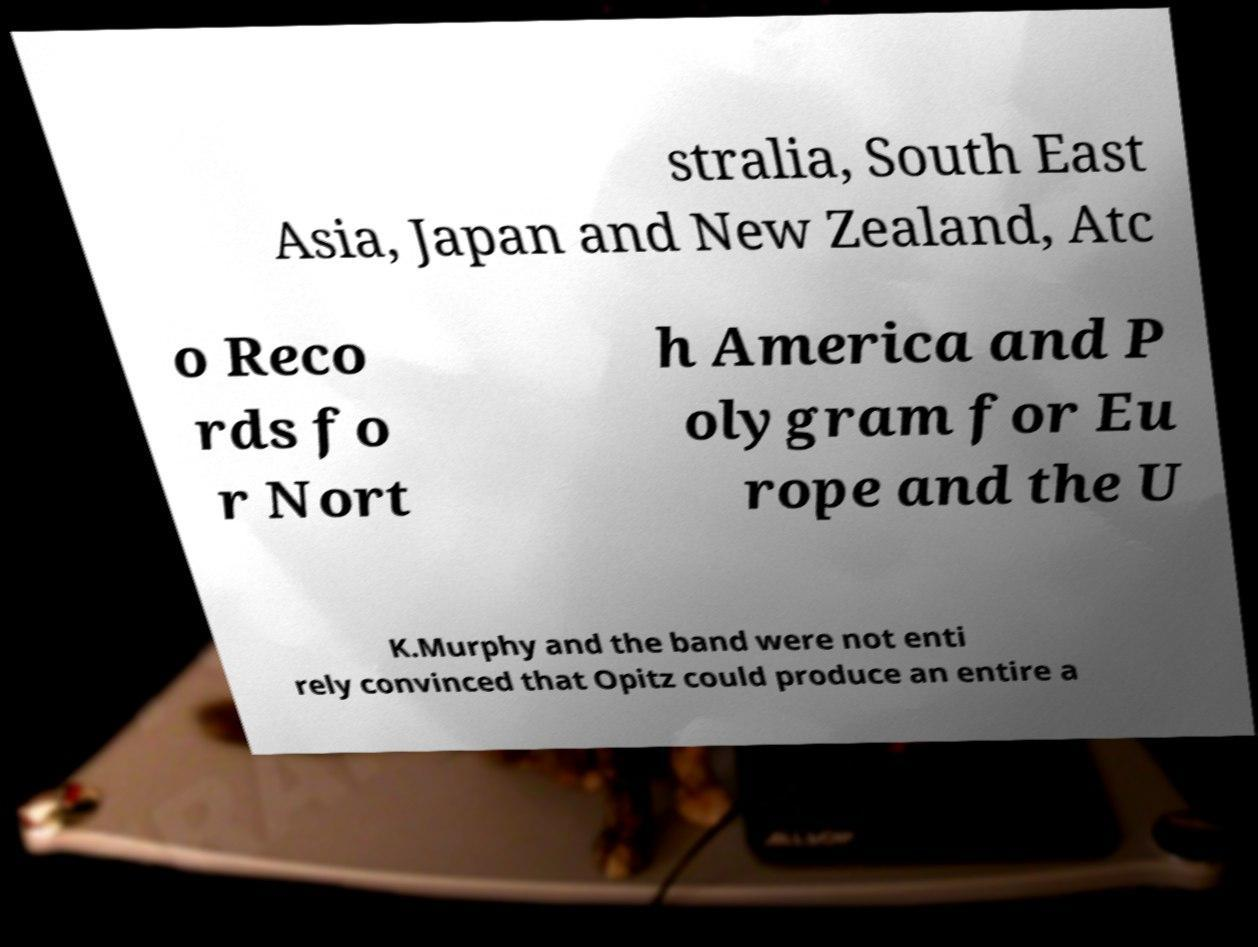I need the written content from this picture converted into text. Can you do that? stralia, South East Asia, Japan and New Zealand, Atc o Reco rds fo r Nort h America and P olygram for Eu rope and the U K.Murphy and the band were not enti rely convinced that Opitz could produce an entire a 